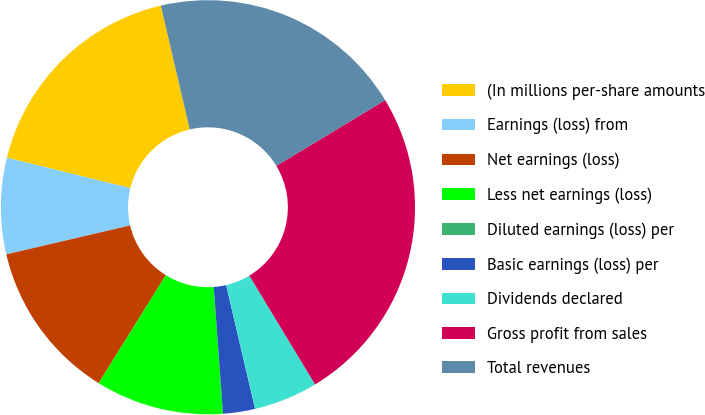Convert chart to OTSL. <chart><loc_0><loc_0><loc_500><loc_500><pie_chart><fcel>(In millions per-share amounts<fcel>Earnings (loss) from<fcel>Net earnings (loss)<fcel>Less net earnings (loss)<fcel>Diluted earnings (loss) per<fcel>Basic earnings (loss) per<fcel>Dividends declared<fcel>Gross profit from sales<fcel>Total revenues<nl><fcel>17.5%<fcel>7.5%<fcel>12.5%<fcel>10.0%<fcel>0.0%<fcel>2.5%<fcel>5.0%<fcel>25.0%<fcel>20.0%<nl></chart> 